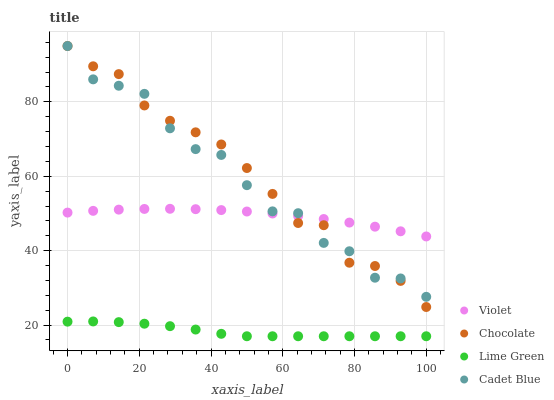Does Lime Green have the minimum area under the curve?
Answer yes or no. Yes. Does Chocolate have the maximum area under the curve?
Answer yes or no. Yes. Does Chocolate have the minimum area under the curve?
Answer yes or no. No. Does Lime Green have the maximum area under the curve?
Answer yes or no. No. Is Violet the smoothest?
Answer yes or no. Yes. Is Cadet Blue the roughest?
Answer yes or no. Yes. Is Chocolate the smoothest?
Answer yes or no. No. Is Chocolate the roughest?
Answer yes or no. No. Does Lime Green have the lowest value?
Answer yes or no. Yes. Does Chocolate have the lowest value?
Answer yes or no. No. Does Chocolate have the highest value?
Answer yes or no. Yes. Does Lime Green have the highest value?
Answer yes or no. No. Is Lime Green less than Cadet Blue?
Answer yes or no. Yes. Is Chocolate greater than Lime Green?
Answer yes or no. Yes. Does Cadet Blue intersect Chocolate?
Answer yes or no. Yes. Is Cadet Blue less than Chocolate?
Answer yes or no. No. Is Cadet Blue greater than Chocolate?
Answer yes or no. No. Does Lime Green intersect Cadet Blue?
Answer yes or no. No. 